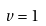Convert formula to latex. <formula><loc_0><loc_0><loc_500><loc_500>v = 1</formula> 